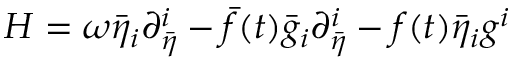<formula> <loc_0><loc_0><loc_500><loc_500>H = \omega { \bar { \eta } } _ { i } { \partial } _ { \bar { \eta } } ^ { i } - \bar { f } ( t ) { \bar { g } } _ { i } { \partial } _ { \bar { \eta } } ^ { i } - f ( t ) { \bar { \eta } } _ { i } g ^ { i }</formula> 